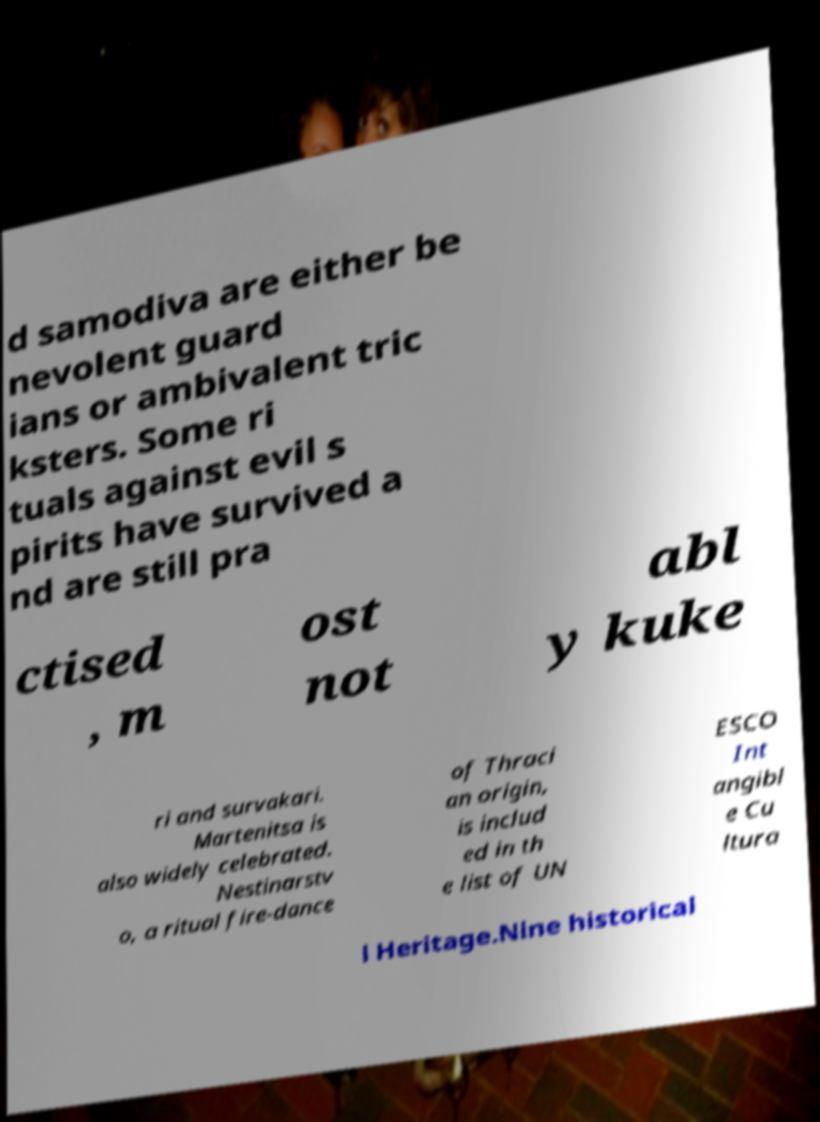For documentation purposes, I need the text within this image transcribed. Could you provide that? d samodiva are either be nevolent guard ians or ambivalent tric ksters. Some ri tuals against evil s pirits have survived a nd are still pra ctised , m ost not abl y kuke ri and survakari. Martenitsa is also widely celebrated. Nestinarstv o, a ritual fire-dance of Thraci an origin, is includ ed in th e list of UN ESCO Int angibl e Cu ltura l Heritage.Nine historical 